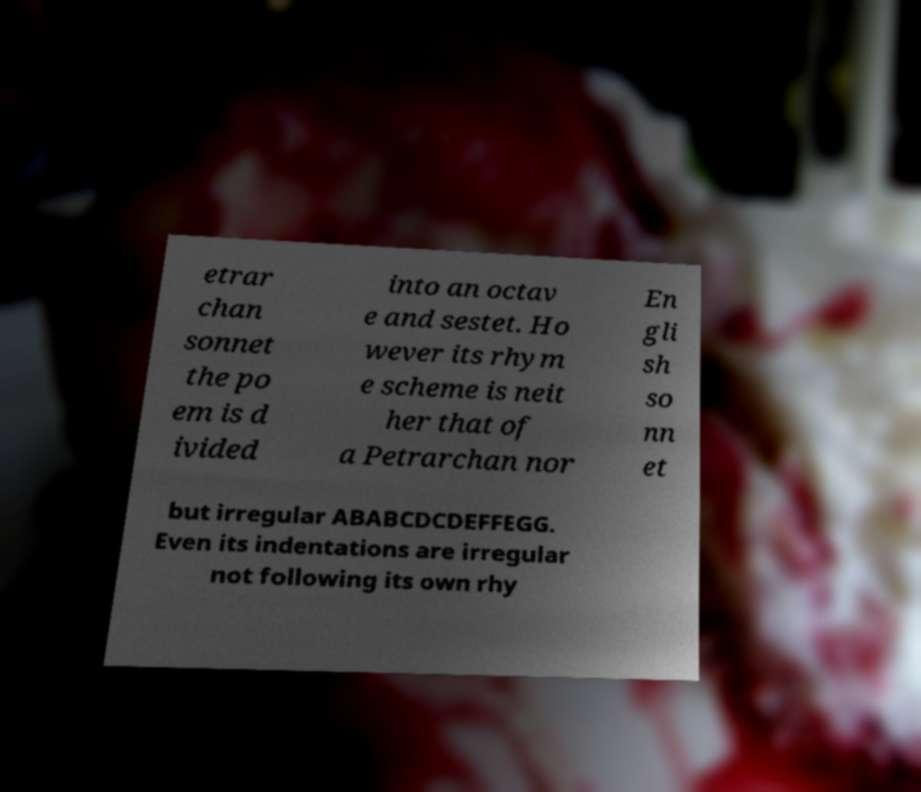For documentation purposes, I need the text within this image transcribed. Could you provide that? etrar chan sonnet the po em is d ivided into an octav e and sestet. Ho wever its rhym e scheme is neit her that of a Petrarchan nor En gli sh so nn et but irregular ABABCDCDEFFEGG. Even its indentations are irregular not following its own rhy 